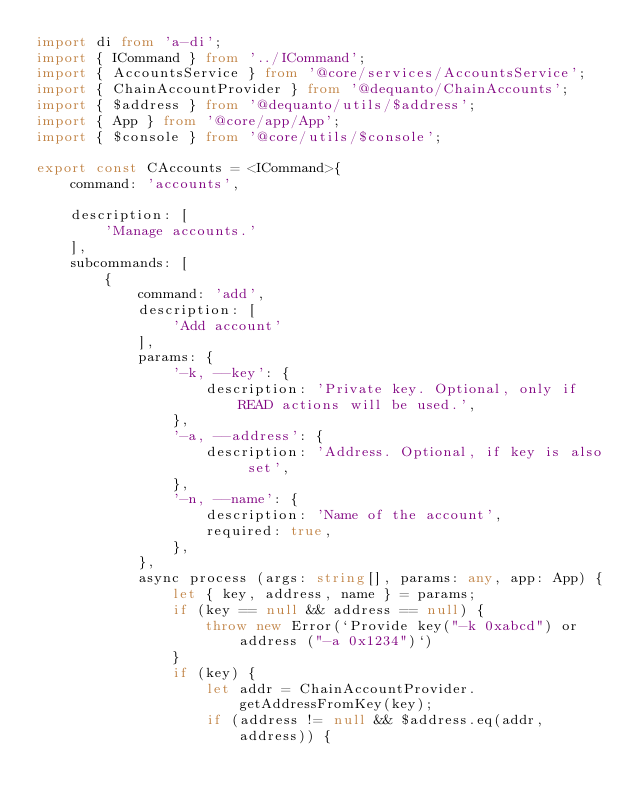Convert code to text. <code><loc_0><loc_0><loc_500><loc_500><_TypeScript_>import di from 'a-di';
import { ICommand } from '../ICommand';
import { AccountsService } from '@core/services/AccountsService';
import { ChainAccountProvider } from '@dequanto/ChainAccounts';
import { $address } from '@dequanto/utils/$address';
import { App } from '@core/app/App';
import { $console } from '@core/utils/$console';

export const CAccounts = <ICommand>{
    command: 'accounts',

    description: [
        'Manage accounts.'
    ],
    subcommands: [
        {
            command: 'add',
            description: [
                'Add account'
            ],
            params: {
                '-k, --key': {
                    description: 'Private key. Optional, only if READ actions will be used.',
                },
                '-a, --address': {
                    description: 'Address. Optional, if key is also set',
                },
                '-n, --name': {
                    description: 'Name of the account',
                    required: true,
                },
            },
            async process (args: string[], params: any, app: App) {
                let { key, address, name } = params;
                if (key == null && address == null) {
                    throw new Error(`Provide key("-k 0xabcd") or address ("-a 0x1234")`)
                }
                if (key) {
                    let addr = ChainAccountProvider.getAddressFromKey(key);
                    if (address != null && $address.eq(addr, address)) {</code> 